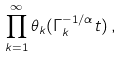<formula> <loc_0><loc_0><loc_500><loc_500>\prod _ { k = 1 } ^ { \infty } \theta _ { k } ( \Gamma _ { k } ^ { - 1 / \alpha } t ) \, ,</formula> 